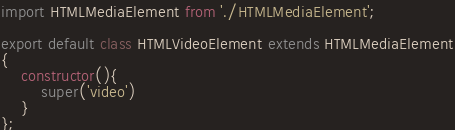Convert code to text. <code><loc_0><loc_0><loc_500><loc_500><_JavaScript_>import HTMLMediaElement from './HTMLMediaElement';

export default class HTMLVideoElement extends HTMLMediaElement
{
    constructor(){
        super('video')
    }
};
</code> 